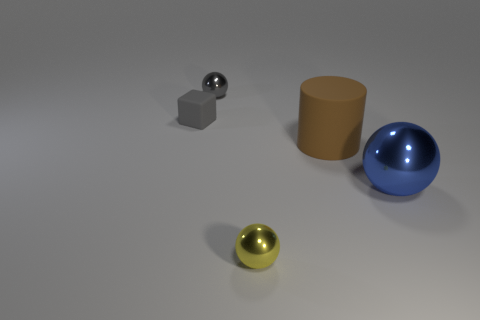Subtract all big blue metal spheres. How many spheres are left? 2 Subtract all gray balls. How many balls are left? 2 Add 3 spheres. How many objects exist? 8 Subtract all cylinders. How many objects are left? 4 Subtract 0 purple cylinders. How many objects are left? 5 Subtract 2 spheres. How many spheres are left? 1 Subtract all gray spheres. Subtract all brown cylinders. How many spheres are left? 2 Subtract all purple matte balls. Subtract all big matte things. How many objects are left? 4 Add 2 big metallic balls. How many big metallic balls are left? 3 Add 5 tiny green objects. How many tiny green objects exist? 5 